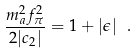Convert formula to latex. <formula><loc_0><loc_0><loc_500><loc_500>\frac { m _ { a } ^ { 2 } f ^ { 2 } _ { \pi } } { 2 | c _ { 2 } | } = 1 + | \epsilon | \ .</formula> 